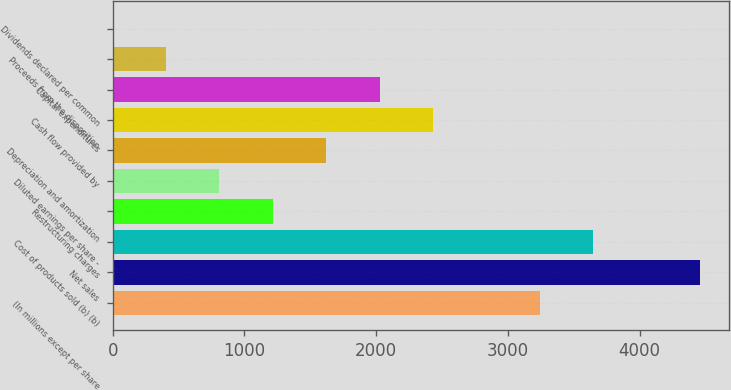<chart> <loc_0><loc_0><loc_500><loc_500><bar_chart><fcel>(In millions except per share<fcel>Net sales<fcel>Cost of products sold (b) (b)<fcel>Restructuring charges<fcel>Diluted earnings per share -<fcel>Depreciation and amortization<fcel>Cash flow provided by<fcel>Capital expenditures<fcel>Proceeds from the disposition<fcel>Dividends declared per common<nl><fcel>3241.3<fcel>4456.6<fcel>3646.4<fcel>1215.8<fcel>810.7<fcel>1620.9<fcel>2431.1<fcel>2026<fcel>405.6<fcel>0.5<nl></chart> 